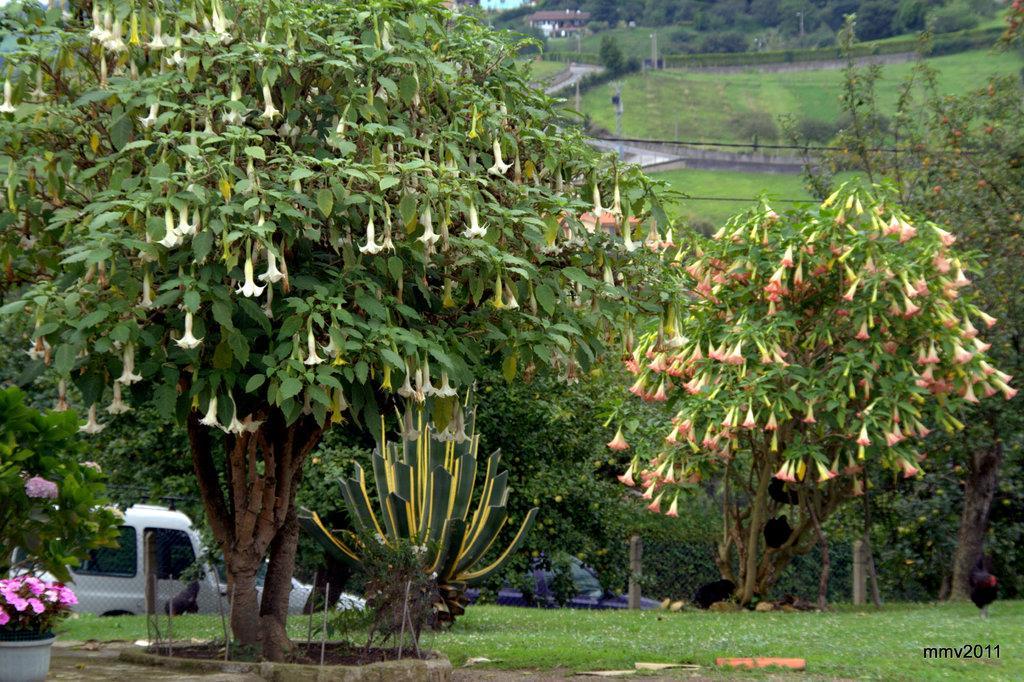Please provide a concise description of this image. There is greenery in the foreground area of the image, there is a net fencing, vehicle, house structure, trees, poles and grassland in the background. 